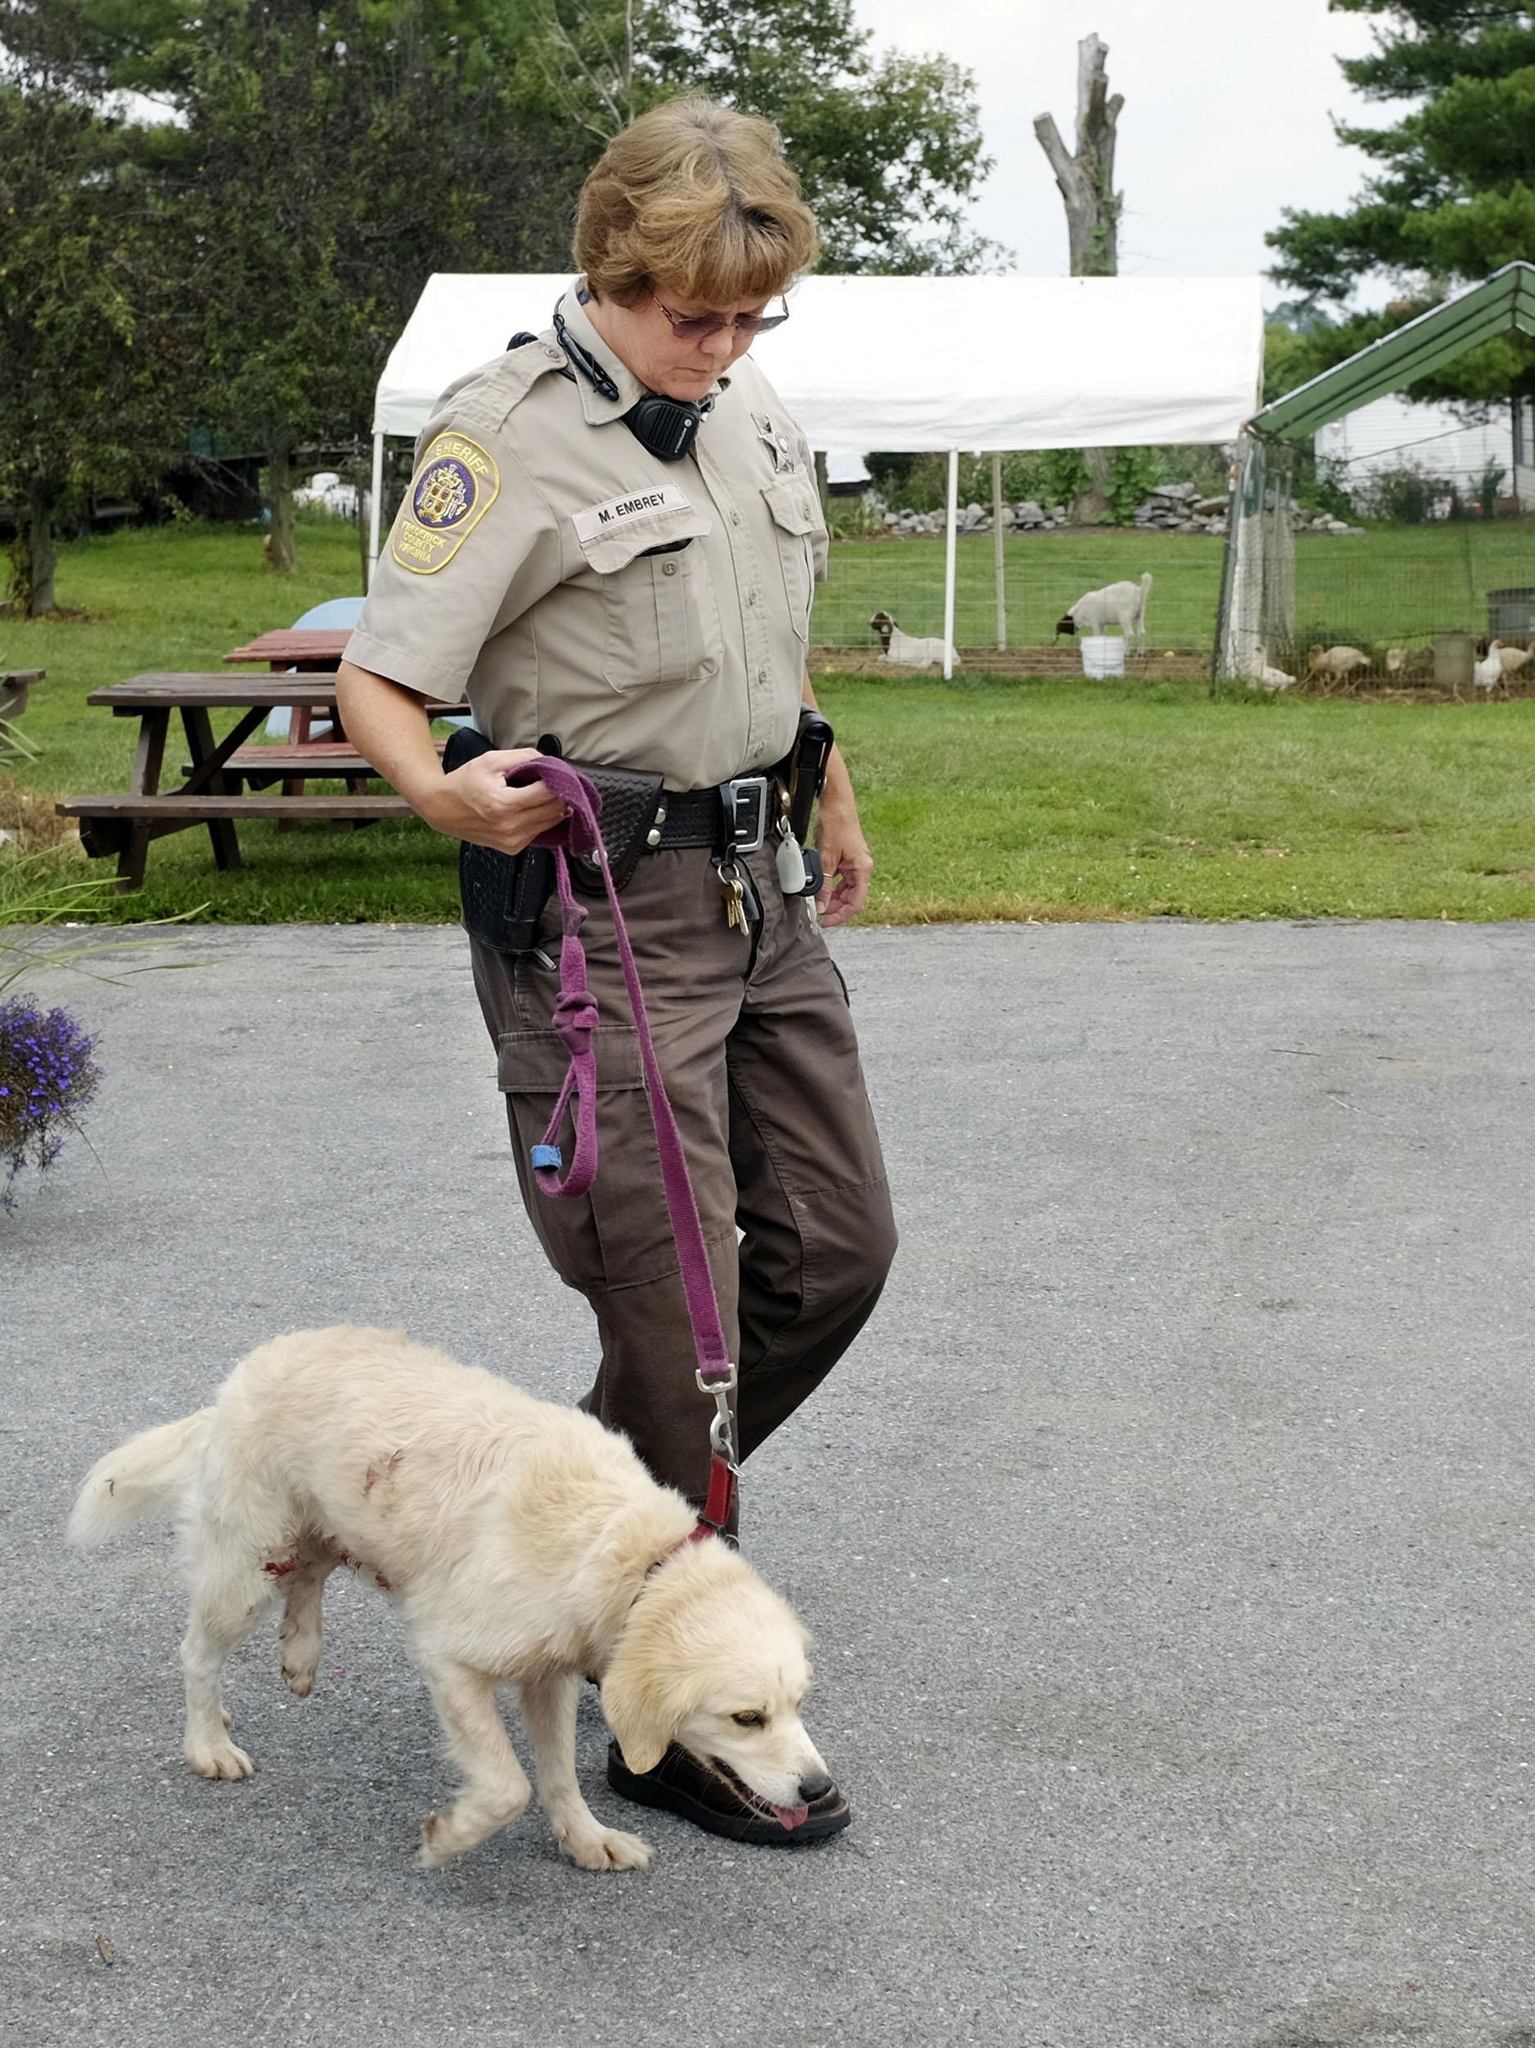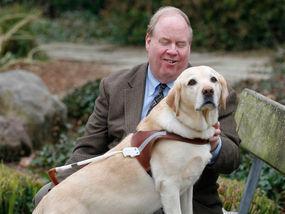The first image is the image on the left, the second image is the image on the right. For the images displayed, is the sentence "A yellow dog is next to a woman." factually correct? Answer yes or no. Yes. The first image is the image on the left, the second image is the image on the right. For the images displayed, is the sentence "There are no humans in the image on the right." factually correct? Answer yes or no. No. 